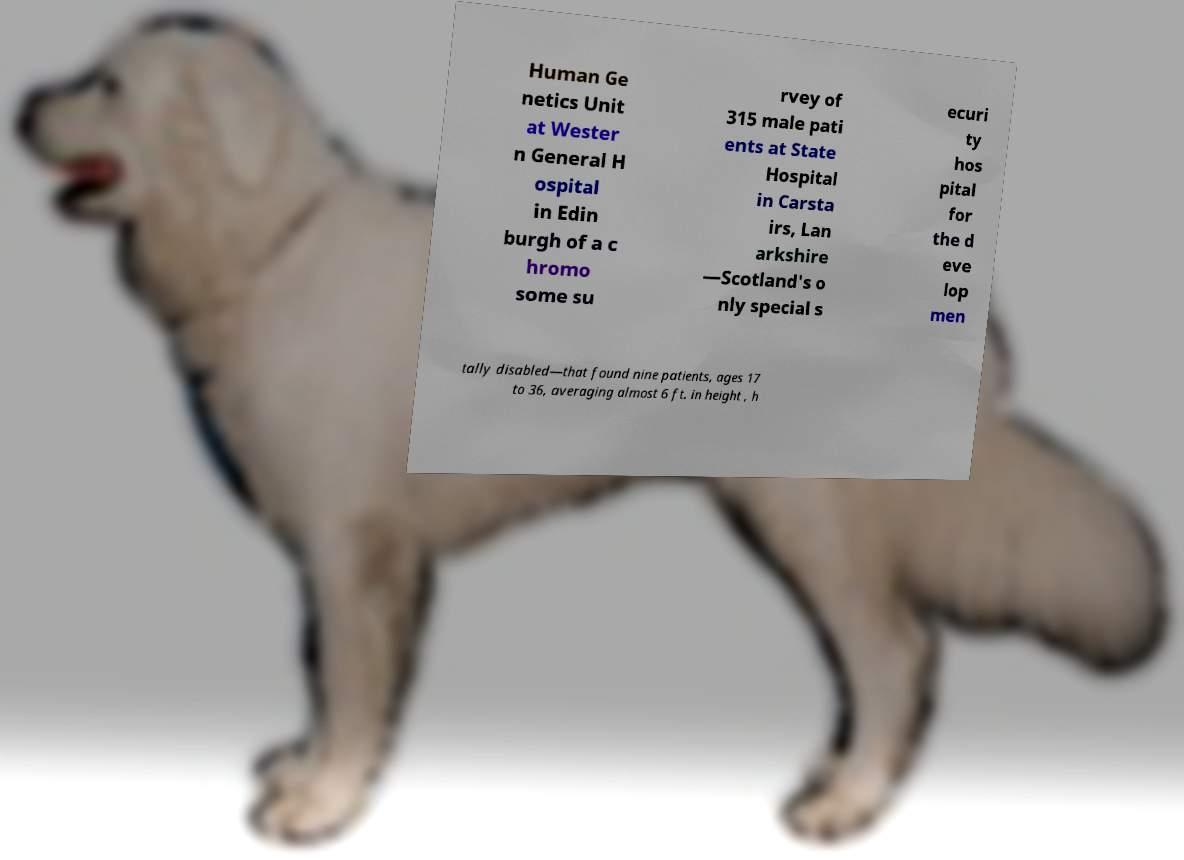Could you assist in decoding the text presented in this image and type it out clearly? Human Ge netics Unit at Wester n General H ospital in Edin burgh of a c hromo some su rvey of 315 male pati ents at State Hospital in Carsta irs, Lan arkshire —Scotland's o nly special s ecuri ty hos pital for the d eve lop men tally disabled—that found nine patients, ages 17 to 36, averaging almost 6 ft. in height , h 